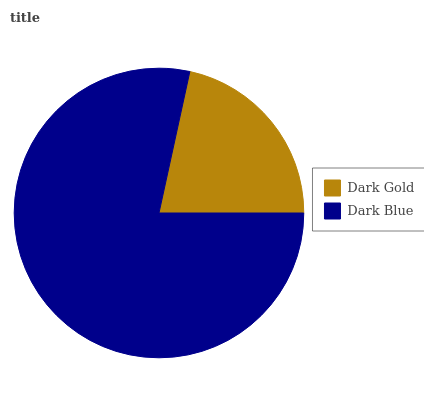Is Dark Gold the minimum?
Answer yes or no. Yes. Is Dark Blue the maximum?
Answer yes or no. Yes. Is Dark Blue the minimum?
Answer yes or no. No. Is Dark Blue greater than Dark Gold?
Answer yes or no. Yes. Is Dark Gold less than Dark Blue?
Answer yes or no. Yes. Is Dark Gold greater than Dark Blue?
Answer yes or no. No. Is Dark Blue less than Dark Gold?
Answer yes or no. No. Is Dark Blue the high median?
Answer yes or no. Yes. Is Dark Gold the low median?
Answer yes or no. Yes. Is Dark Gold the high median?
Answer yes or no. No. Is Dark Blue the low median?
Answer yes or no. No. 